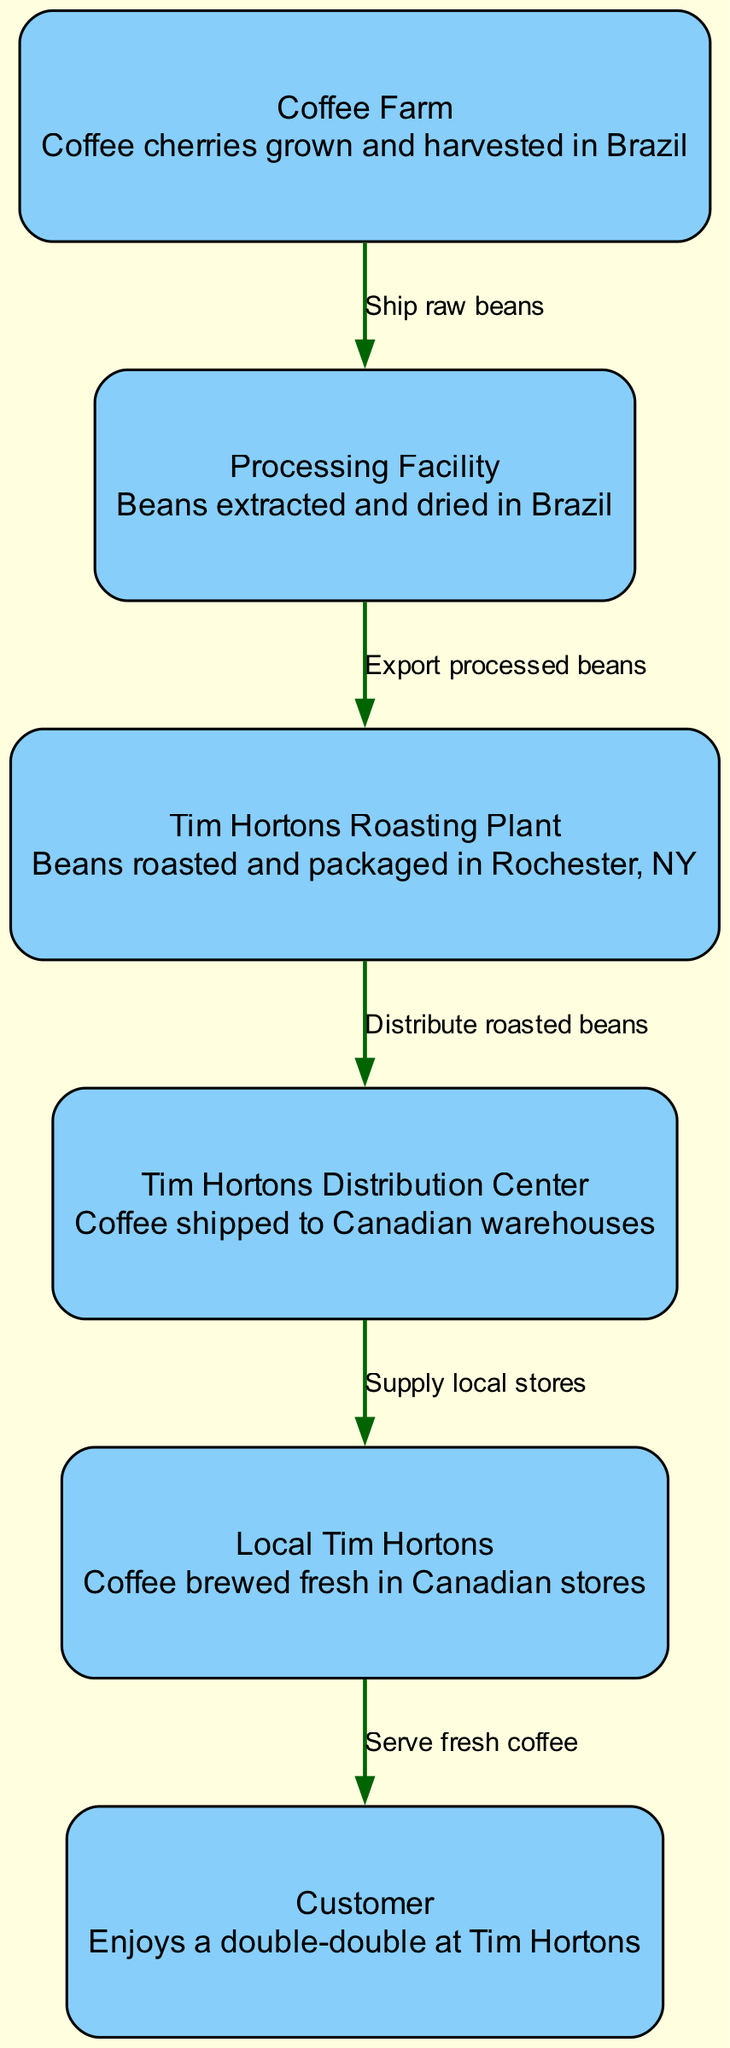What is the first node in the journey? The diagram starts at the "Coffee Farm," which is the initial point where coffee cherries are grown and harvested.
Answer: Coffee Farm How many nodes are present in the diagram? By counting the distinct locations represented, including coffee farms, processing facilities, roasting plants, distribution centers, local stores, and the customer, we find a total of six nodes.
Answer: 6 What is the final node of the diagram? The diagram concludes with the "Customer," indicating the end of the coffee journey where the coffee is enjoyed.
Answer: Customer What label describes the connection from the Processing Facility to the Tim Hortons Roasting Plant? Referring to the edge connecting these two nodes, the label "Export processed beans" describes this relationship, indicating the action taken as the beans move to the roasting plant.
Answer: Export processed beans Which facility is responsible for brewing the coffee? According to the diagram, the "Local Tim Hortons" node is indicated as the location where the coffee is brewed fresh for customers.
Answer: Local Tim Hortons How many edges are depicted in the diagram? Each directional connection between the nodes represents an edge; counting these, we find there are five edges connecting the various stages in the journey.
Answer: 5 What is the flow of coffee after it leaves the Processing Facility? Upon leaving the Processing Facility, the coffee beans are exported to the Tim Hortons Roasting Plant, where they are roasted and packaged before distribution.
Answer: Tim Hortons Roasting Plant Which edge indicates the supply chain to local stores? The diagram clearly shows the edge labeled "Supply local stores," which connects the Tim Hortons Distribution Center and the Local Tim Hortons, illustrating how coffee reaches retail locations.
Answer: Supply local stores What is the purpose of the Tim Hortons Roasting Plant in the diagram? The purpose is defined as roasting and packaging the beans that arrive from the Processing Facility, preparing them before they are shipped to distribution centers.
Answer: Roasting and packaged 